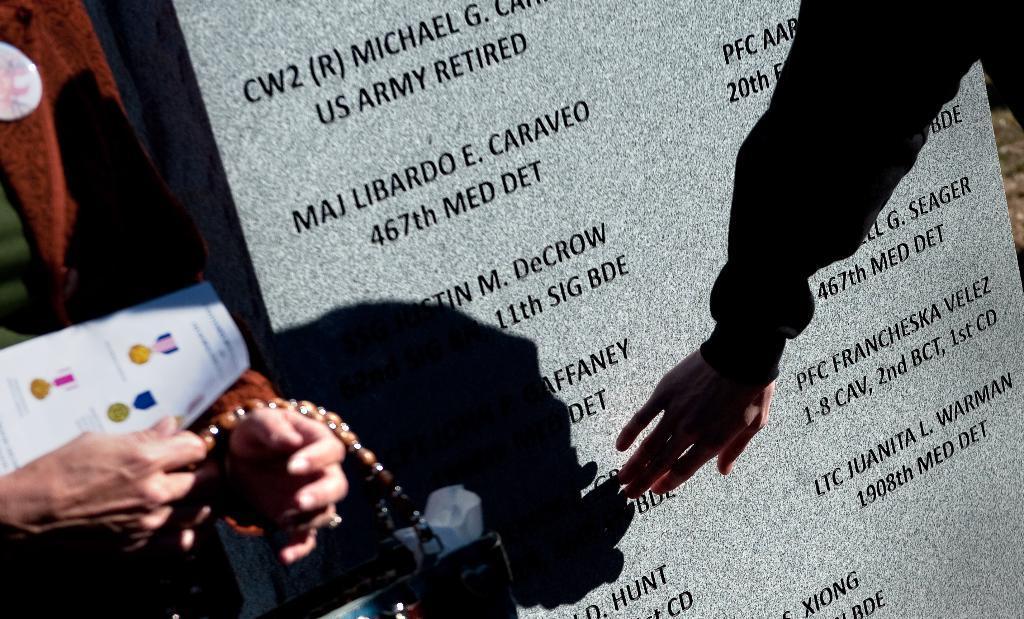Please provide a concise description of this image. In the image we can see human hands. Here we can see a neck chain, paper and marble stone, on it there is a text. 